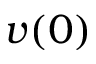<formula> <loc_0><loc_0><loc_500><loc_500>v ( 0 )</formula> 